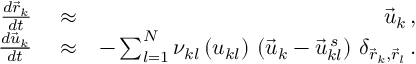Convert formula to latex. <formula><loc_0><loc_0><loc_500><loc_500>\begin{array} { r l r } { \frac { d \vec { r } _ { k } } { d t } } & \approx } & { \vec { u } _ { k } \, , } \\ { \frac { d \vec { u } _ { k } } { d t } } & \approx } & { - \sum _ { l = 1 } ^ { N } \nu _ { k l } \left ( u _ { k l } \right ) \, \left ( \vec { u } _ { k } - \vec { u } _ { k l } ^ { \, s } \right ) \, \delta _ { \vec { r } _ { k } , \vec { r } _ { l } } \, . } \end{array}</formula> 